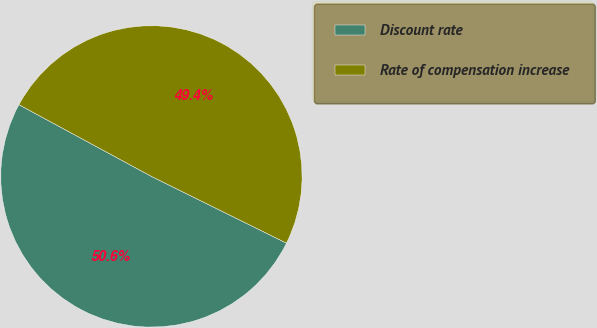Convert chart to OTSL. <chart><loc_0><loc_0><loc_500><loc_500><pie_chart><fcel>Discount rate<fcel>Rate of compensation increase<nl><fcel>50.59%<fcel>49.41%<nl></chart> 